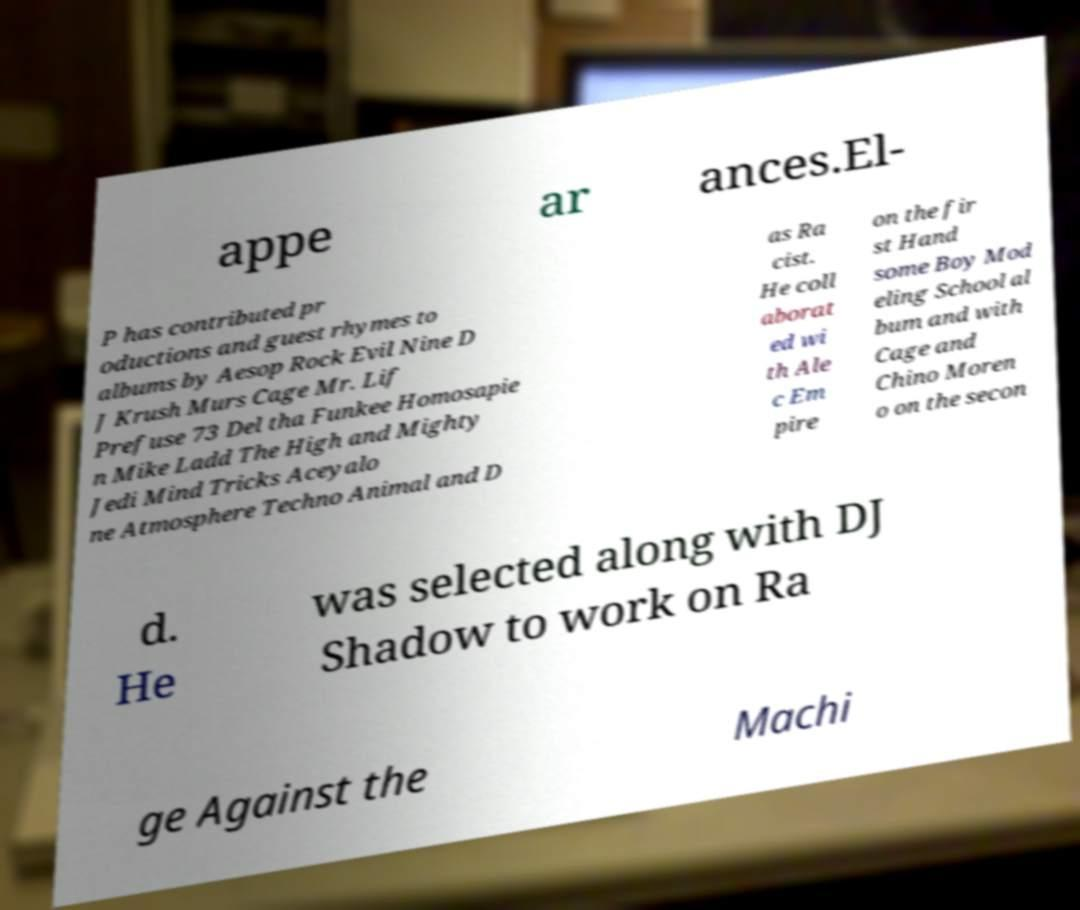There's text embedded in this image that I need extracted. Can you transcribe it verbatim? appe ar ances.El- P has contributed pr oductions and guest rhymes to albums by Aesop Rock Evil Nine D J Krush Murs Cage Mr. Lif Prefuse 73 Del tha Funkee Homosapie n Mike Ladd The High and Mighty Jedi Mind Tricks Aceyalo ne Atmosphere Techno Animal and D as Ra cist. He coll aborat ed wi th Ale c Em pire on the fir st Hand some Boy Mod eling School al bum and with Cage and Chino Moren o on the secon d. He was selected along with DJ Shadow to work on Ra ge Against the Machi 